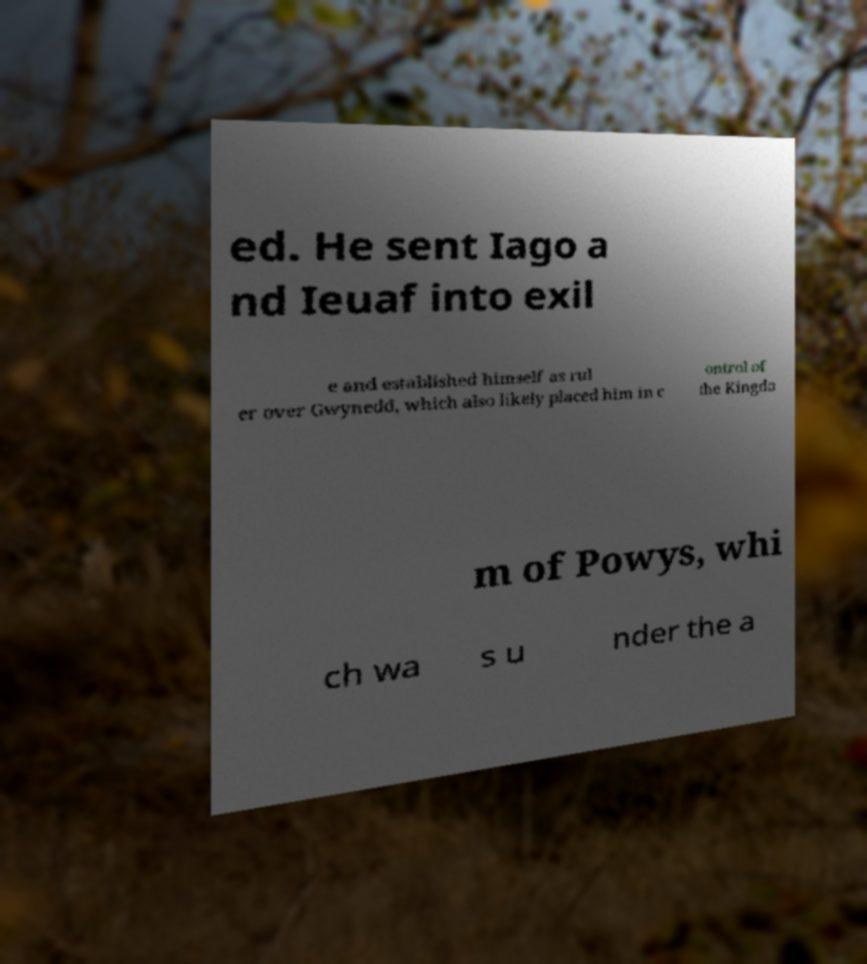Please identify and transcribe the text found in this image. ed. He sent Iago a nd Ieuaf into exil e and established himself as rul er over Gwynedd, which also likely placed him in c ontrol of the Kingdo m of Powys, whi ch wa s u nder the a 